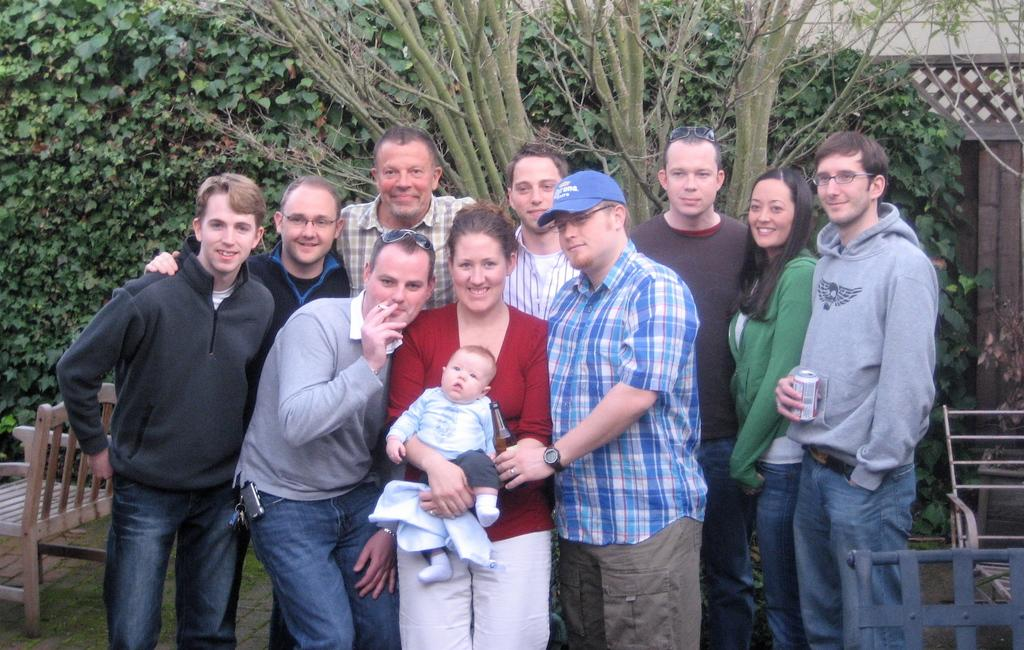How many people are in the image? There is a group of persons in the image. What are the people in the image doing? The persons are standing and smiling. What can be seen in the background of the image? There are trees and a chair in the background of the image. What type of ground is visible in the image? There is grass on the ground in the image. What type of attack is being carried out by the hands in the image? There is no attack or hands present in the image. Are the people in the image engaged in a fight? No, the people in the image are standing and smiling, not fighting. 